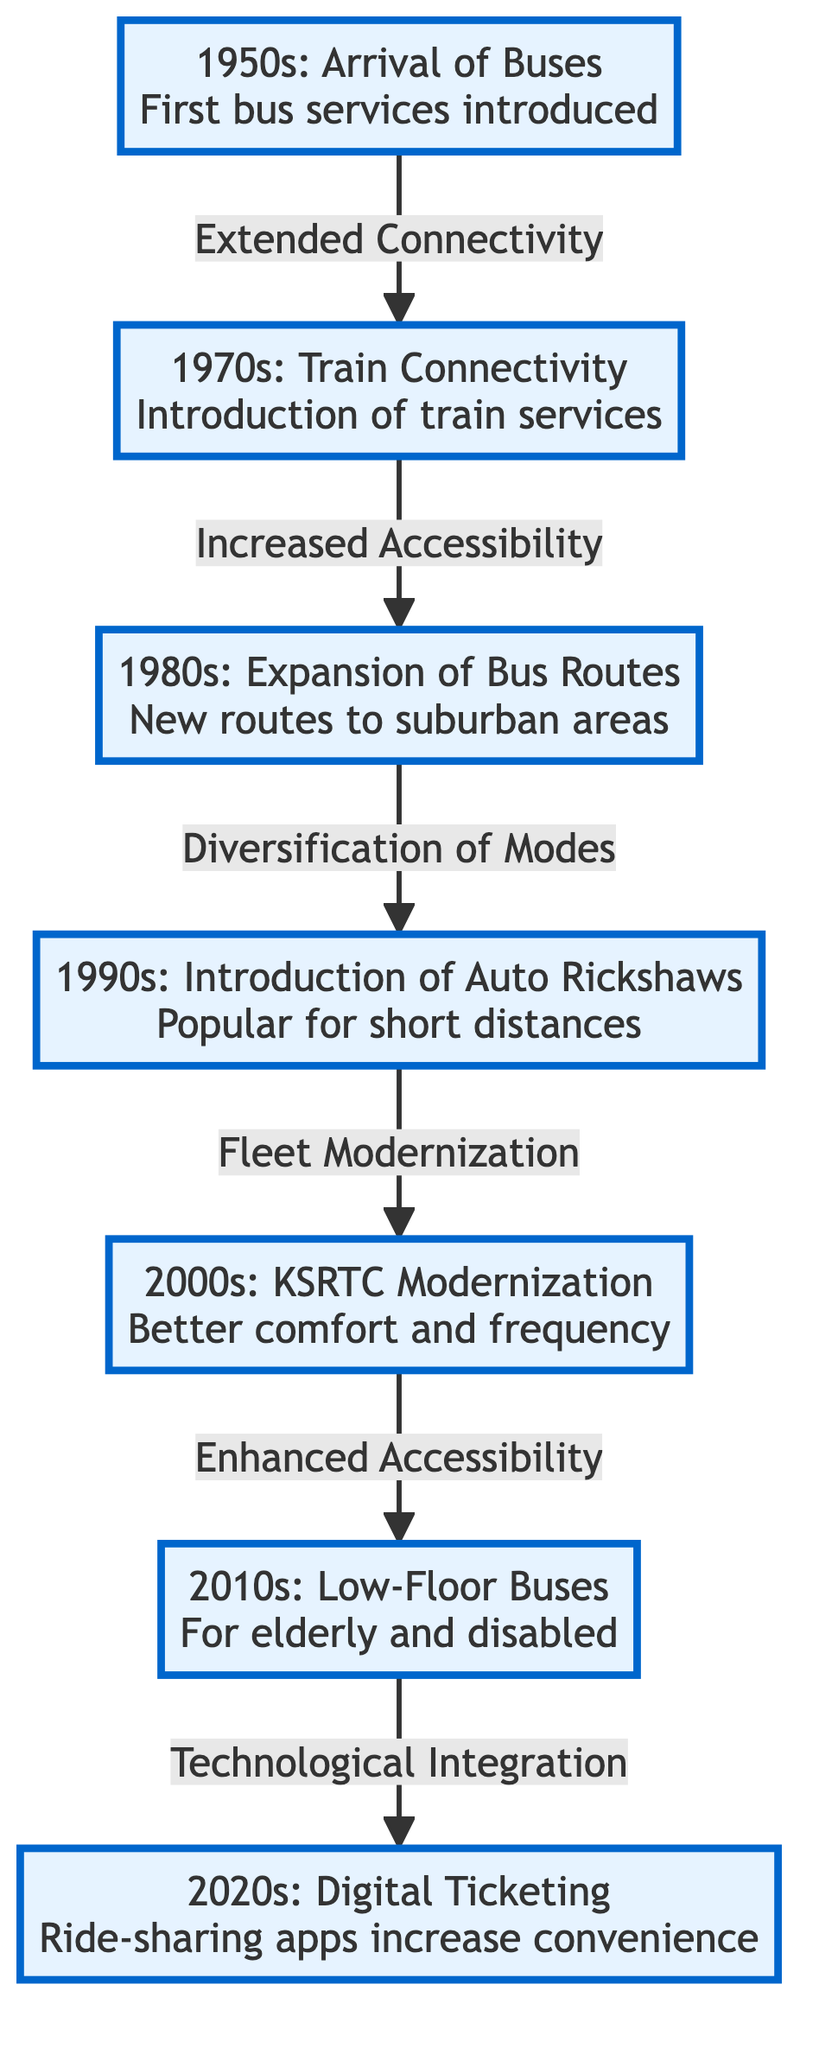What decade saw the introduction of train services in Kozhikode? The diagram indicates that the 1970s marked the introduction of train services. This can be found directly in the node labeled "1970s."
Answer: 1970s What transportation mode was introduced in the 1990s? According to the diagram, the 1990s saw the introduction of auto rickshaws as a popular choice for short distances. This is explicitly stated in the "1990s" node.
Answer: Auto Rickshaws How many decades are represented in the diagram? The diagram features a total of seven distinct decades, which can be counted from the nodes displayed: 1950s, 1970s, 1980s, 1990s, 2000s, 2010s, and 2020s.
Answer: 7 What improvement occurred in the 2000s compared to previous decades? The 2000s included modernization of KSRTC, which brought better comfort and frequency to bus services, thus improving the transportation system significantly. This is noted in the "2000s" node.
Answer: KSRTC Modernization Which decade's transportation development led to the introduction of low-floor buses? The 2010s is specifically highlighted in the diagram for the introduction of low-floor buses, making transportation more accessible for the elderly and disabled. This connection is made directly from the "Enhanced Accessibility" description.
Answer: 2010s What is the primary innovation associated with the 2020s? The primary innovation indicated in the 2020s node of the diagram is digital ticketing, along with the rise of ride-sharing apps that increased convenience. This information is clearly outlined in the "2020s" statement.
Answer: Digital Ticketing How did the introduction of bus services in the 1950s influence train connectivity in the 1970s? The diagram illustrates that the bus services introduced in the 1950s led to "Extended Connectivity," which then set the stage for increased accessibility and the introduction of train services in the 1970s. Therefore, bus services were foundational for train connectivity later on.
Answer: Extended Connectivity What significant change characterized the 1980s in Kozhikode's transportation? The 1980s are characterized by the expansion of bus routes into suburban areas, which is denoted in the relevant node. This reflects a significant transition towards diversifying transportation options.
Answer: Expansion of Bus Routes 